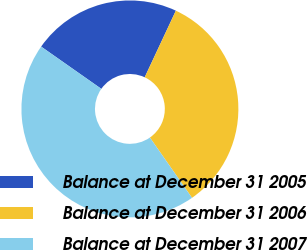<chart> <loc_0><loc_0><loc_500><loc_500><pie_chart><fcel>Balance at December 31 2005<fcel>Balance at December 31 2006<fcel>Balance at December 31 2007<nl><fcel>22.22%<fcel>33.33%<fcel>44.44%<nl></chart> 